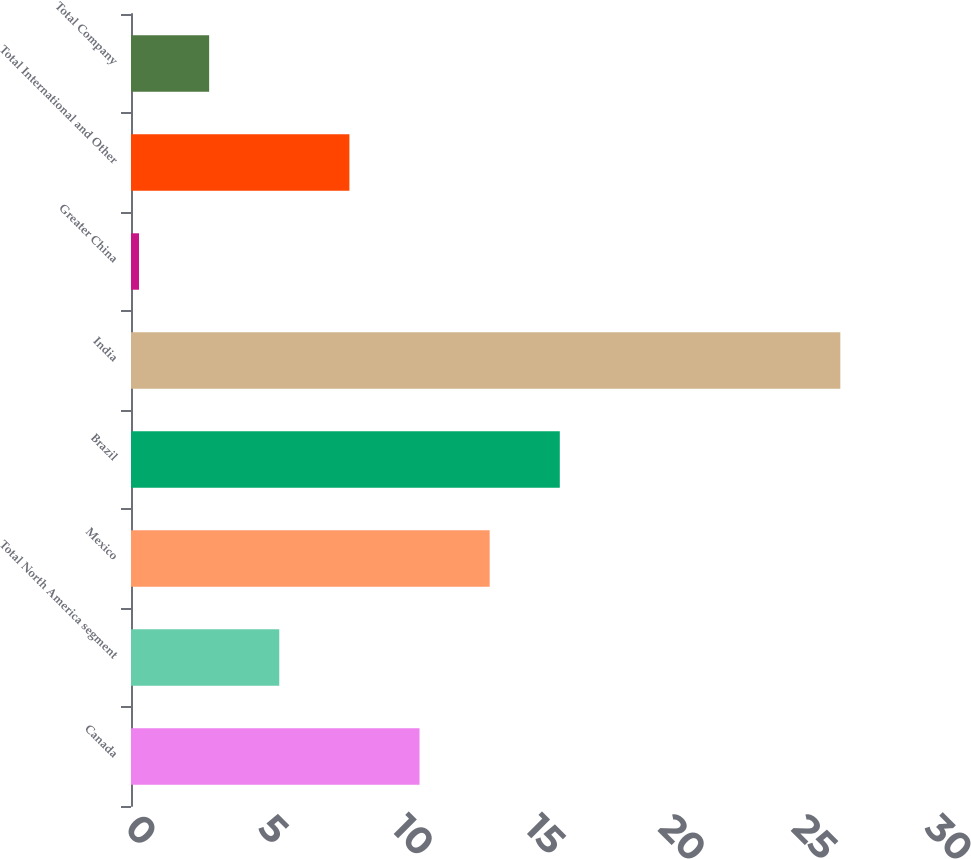<chart> <loc_0><loc_0><loc_500><loc_500><bar_chart><fcel>Canada<fcel>Total North America segment<fcel>Mexico<fcel>Brazil<fcel>India<fcel>Greater China<fcel>Total International and Other<fcel>Total Company<nl><fcel>10.82<fcel>5.56<fcel>13.45<fcel>16.08<fcel>26.6<fcel>0.3<fcel>8.19<fcel>2.93<nl></chart> 